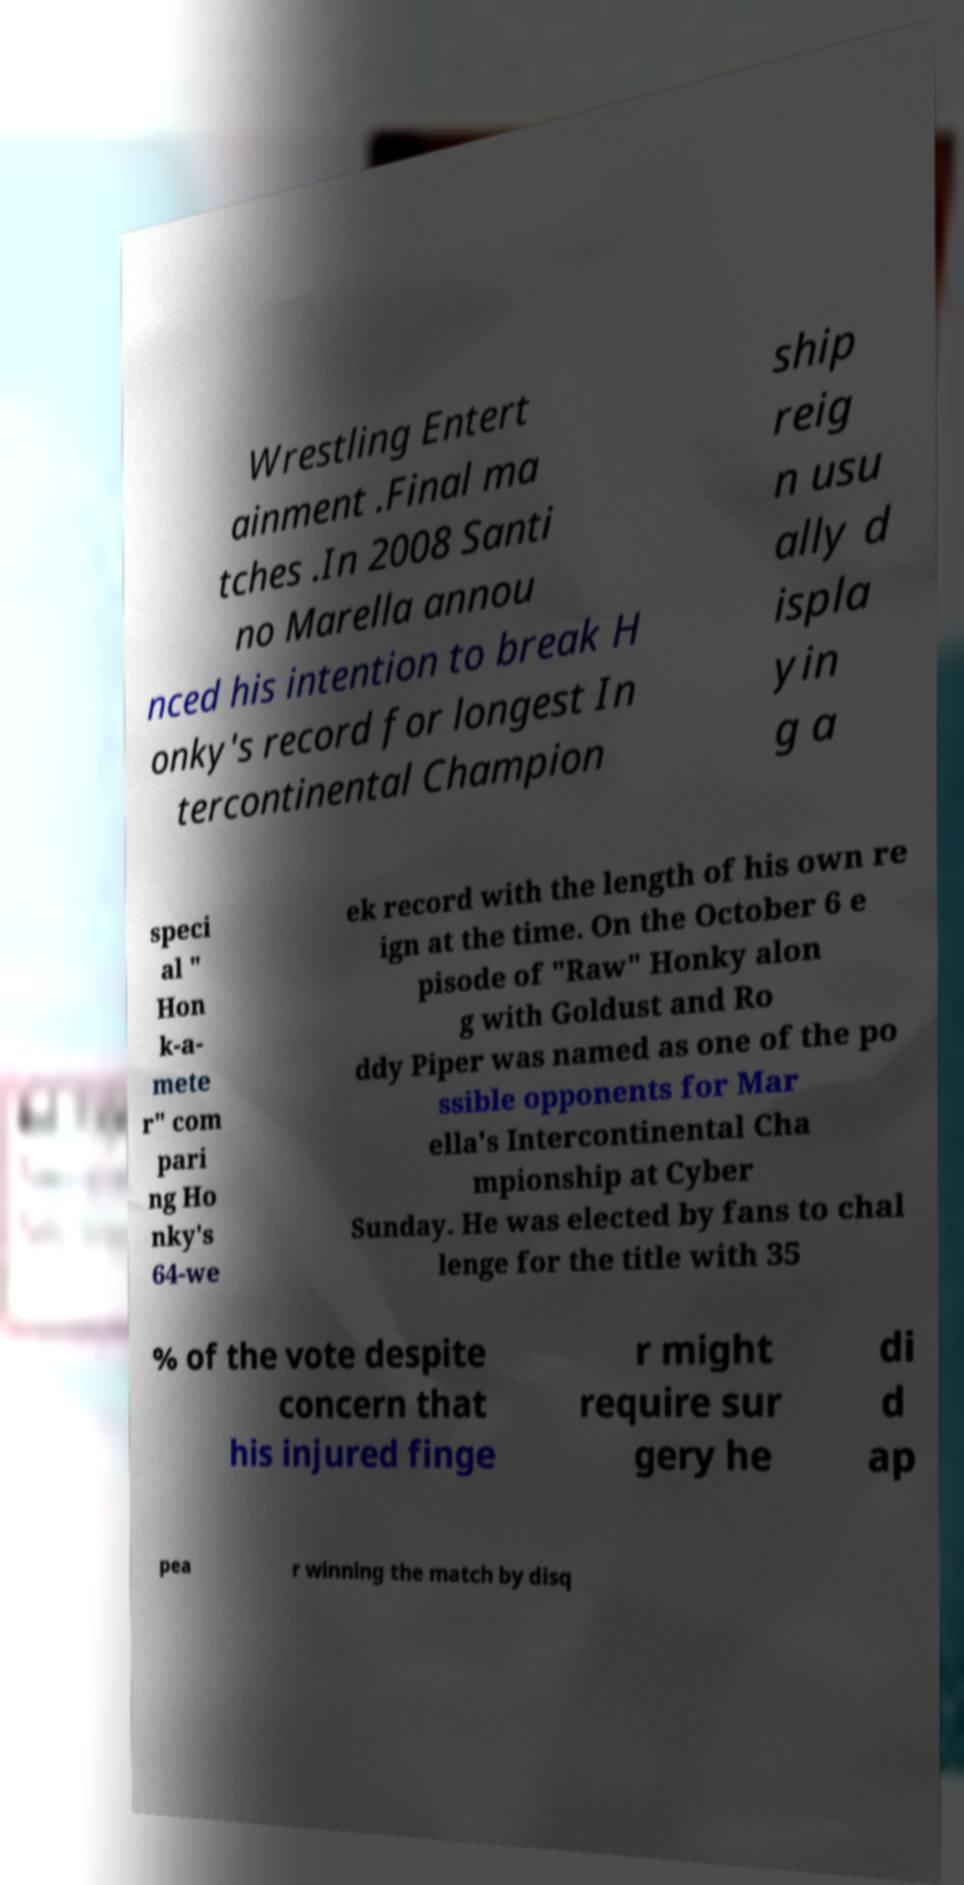I need the written content from this picture converted into text. Can you do that? Wrestling Entert ainment .Final ma tches .In 2008 Santi no Marella annou nced his intention to break H onky's record for longest In tercontinental Champion ship reig n usu ally d ispla yin g a speci al " Hon k-a- mete r" com pari ng Ho nky's 64-we ek record with the length of his own re ign at the time. On the October 6 e pisode of "Raw" Honky alon g with Goldust and Ro ddy Piper was named as one of the po ssible opponents for Mar ella's Intercontinental Cha mpionship at Cyber Sunday. He was elected by fans to chal lenge for the title with 35 % of the vote despite concern that his injured finge r might require sur gery he di d ap pea r winning the match by disq 